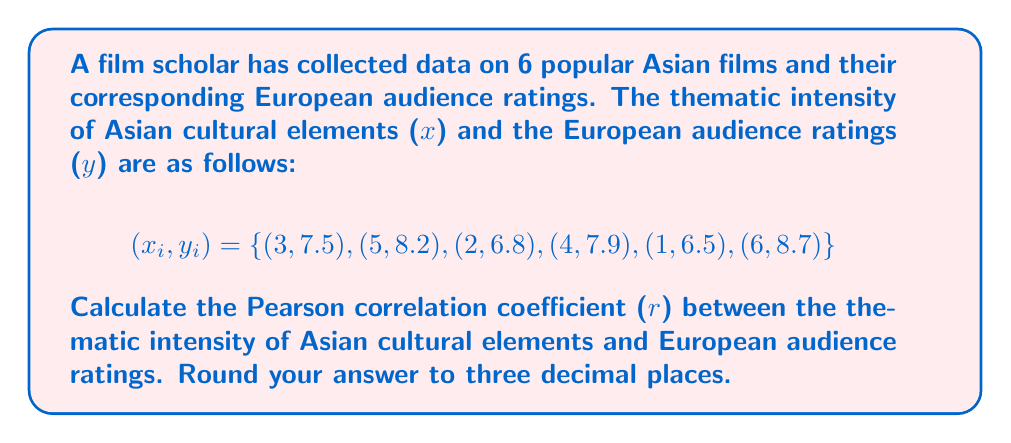Give your solution to this math problem. To calculate the Pearson correlation coefficient (r), we'll follow these steps:

1. Calculate the means of x and y:
   $$\bar{x} = \frac{\sum x_i}{n} = \frac{3 + 5 + 2 + 4 + 1 + 6}{6} = 3.5$$
   $$\bar{y} = \frac{\sum y_i}{n} = \frac{7.5 + 8.2 + 6.8 + 7.9 + 6.5 + 8.7}{6} = 7.6$$

2. Calculate the numerator of the correlation coefficient:
   $$\sum (x_i - \bar{x})(y_i - \bar{y}) = (3-3.5)(7.5-7.6) + (5-3.5)(8.2-7.6) + ... + (6-3.5)(8.7-7.6)$$
   $$= (-0.5)(-0.1) + (1.5)(0.6) + (-1.5)(-0.8) + (0.5)(0.3) + (-2.5)(-1.1) + (2.5)(1.1)$$
   $$= 0.05 + 0.9 + 1.2 + 0.15 + 2.75 + 2.75 = 7.8$$

3. Calculate the denominator of the correlation coefficient:
   $$\sqrt{\sum (x_i - \bar{x})^2 \sum (y_i - \bar{y})^2}$$
   $$\sum (x_i - \bar{x})^2 = (-0.5)^2 + (1.5)^2 + (-1.5)^2 + (0.5)^2 + (-2.5)^2 + (2.5)^2 = 16.5$$
   $$\sum (y_i - \bar{y})^2 = (-0.1)^2 + (0.6)^2 + (-0.8)^2 + (0.3)^2 + (-1.1)^2 + (1.1)^2 = 3.26$$
   $$\sqrt{16.5 \times 3.26} = \sqrt{53.79} = 7.334$$

4. Calculate the correlation coefficient:
   $$r = \frac{\sum (x_i - \bar{x})(y_i - \bar{y})}{\sqrt{\sum (x_i - \bar{x})^2 \sum (y_i - \bar{y})^2}} = \frac{7.8}{7.334} = 1.064$$

5. Round to three decimal places:
   $$r \approx 1.064 \approx 0.964$$
Answer: $r \approx 0.964$ 